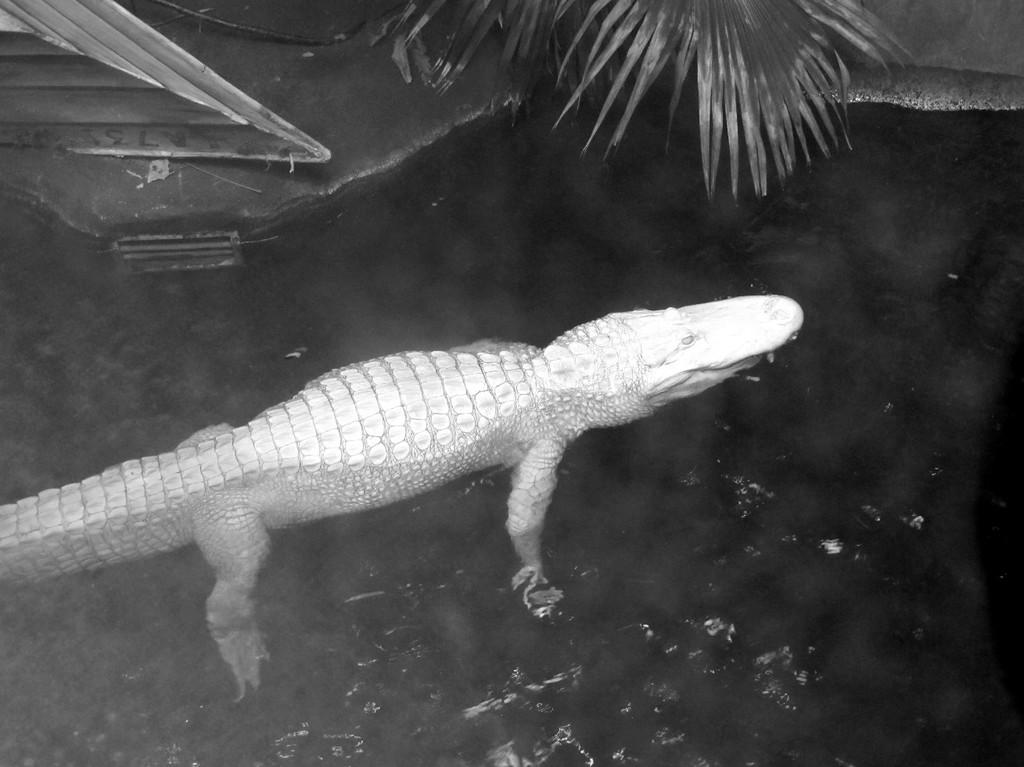What animal can be seen in the water in the image? There is a crocodile in the water in the image. What type of vegetation is visible at the top of the image? There is a tree visible at the top of the image. What type of salt is being used to season the crocodile in the image? There is no salt or seasoning present in the image; it only features a crocodile in the water and a tree at the top. 